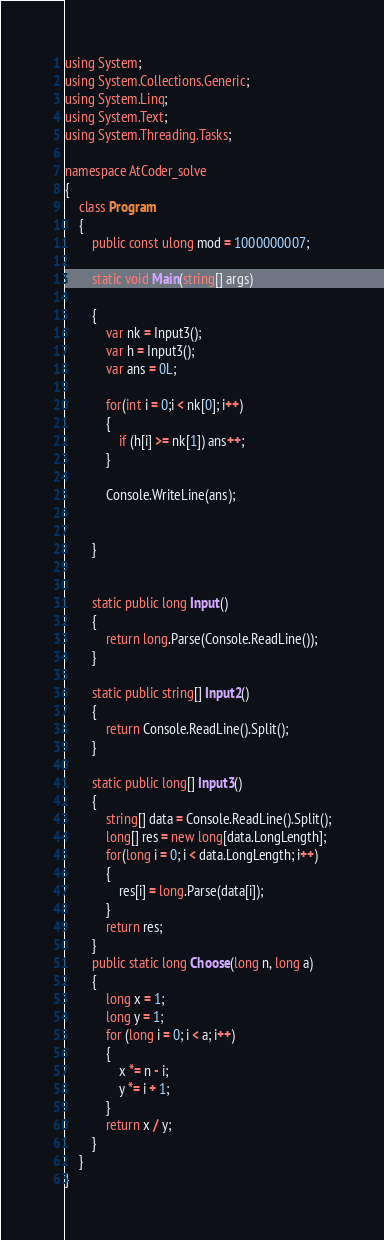<code> <loc_0><loc_0><loc_500><loc_500><_C#_>using System;
using System.Collections.Generic;
using System.Linq;
using System.Text;
using System.Threading.Tasks;

namespace AtCoder_solve
{
    class Program
    {
        public const ulong mod = 1000000007;

        static void Main(string[] args)

        {
            var nk = Input3();
            var h = Input3();
            var ans = 0L;

            for(int i = 0;i < nk[0]; i++)
            {
                if (h[i] >= nk[1]) ans++;  
            }

            Console.WriteLine(ans);


        }

       
        static public long Input()
        {
            return long.Parse(Console.ReadLine());
        }

        static public string[] Input2()
        {
            return Console.ReadLine().Split();
        }

        static public long[] Input3()
        {
            string[] data = Console.ReadLine().Split();
            long[] res = new long[data.LongLength];
            for(long i = 0; i < data.LongLength; i++)
            {
                res[i] = long.Parse(data[i]);
            }
            return res;
        }
        public static long Choose(long n, long a)
        {
            long x = 1;
            long y = 1;
            for (long i = 0; i < a; i++)
            {
                x *= n - i;
                y *= i + 1;
            }
            return x / y;
        }
    }
}
</code> 